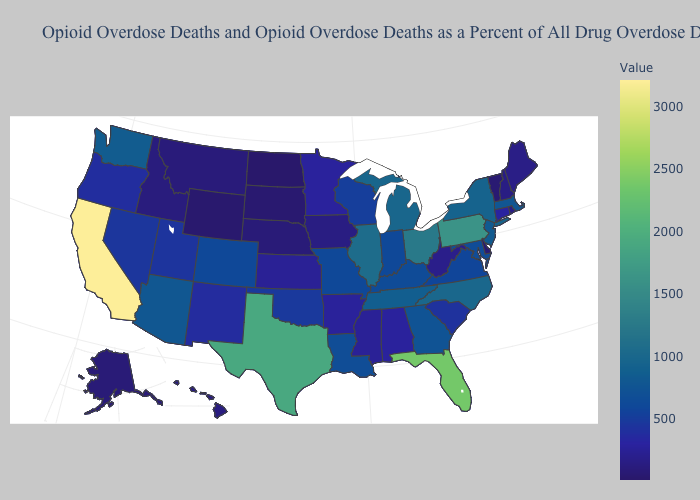Which states have the highest value in the USA?
Concise answer only. California. Does Tennessee have the lowest value in the South?
Give a very brief answer. No. Does the map have missing data?
Short answer required. No. Does Maine have the highest value in the Northeast?
Write a very short answer. No. Does North Dakota have the highest value in the MidWest?
Be succinct. No. 